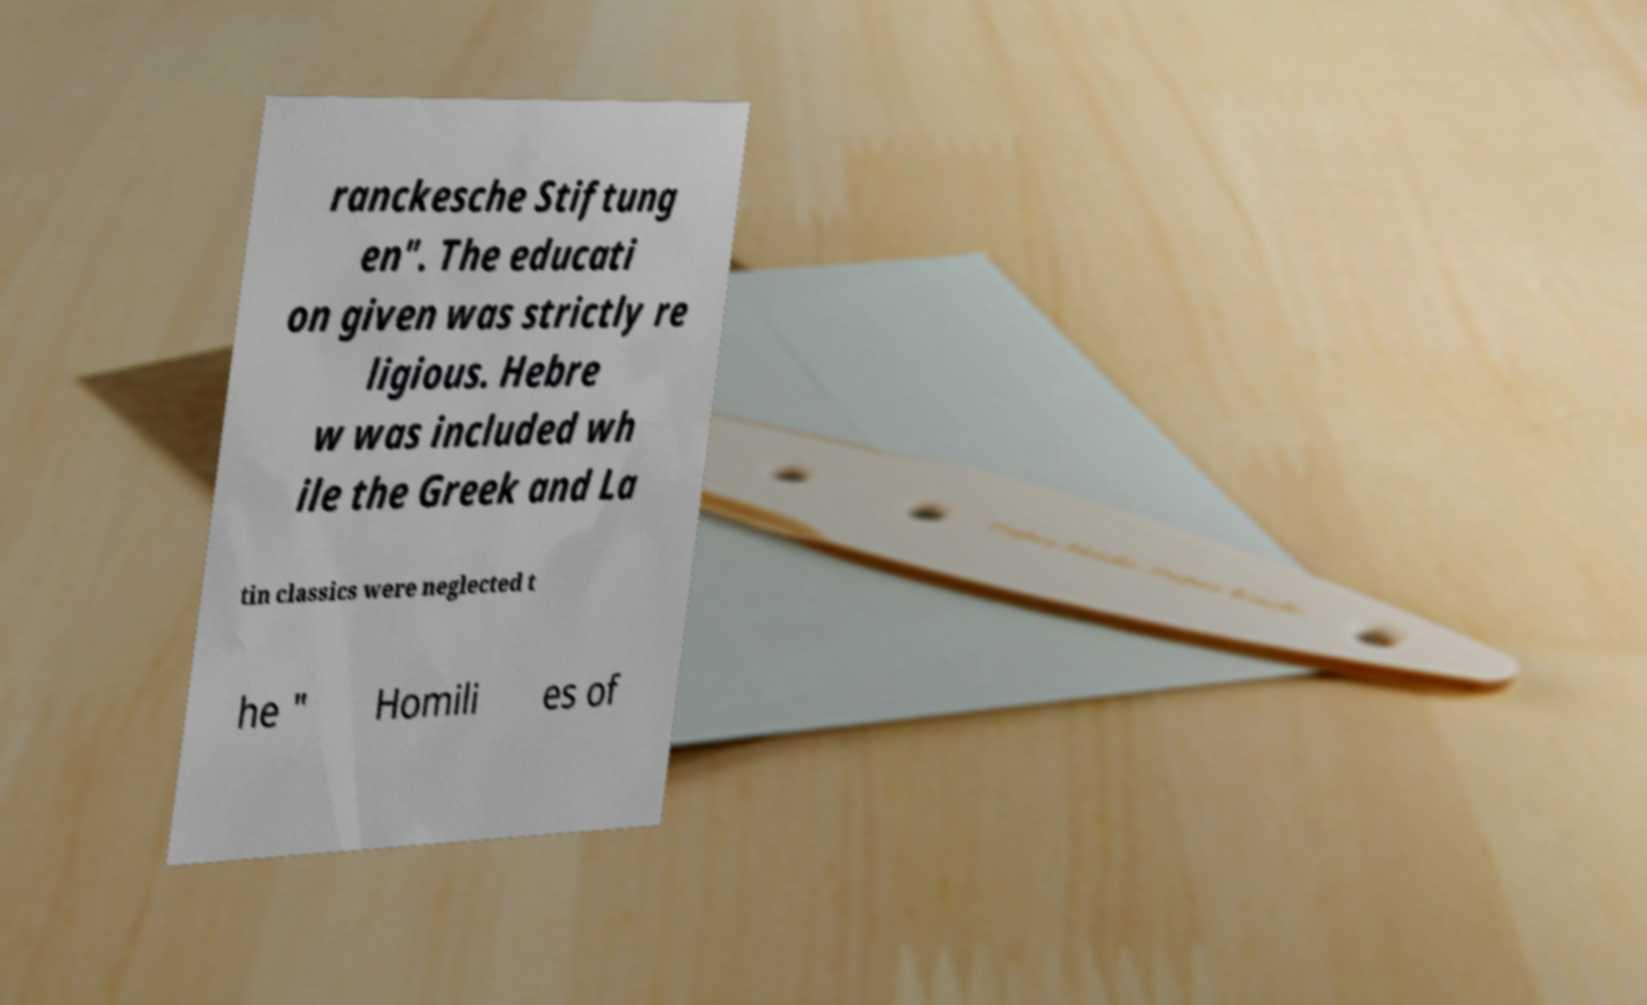Can you read and provide the text displayed in the image?This photo seems to have some interesting text. Can you extract and type it out for me? ranckesche Stiftung en". The educati on given was strictly re ligious. Hebre w was included wh ile the Greek and La tin classics were neglected t he " Homili es of 